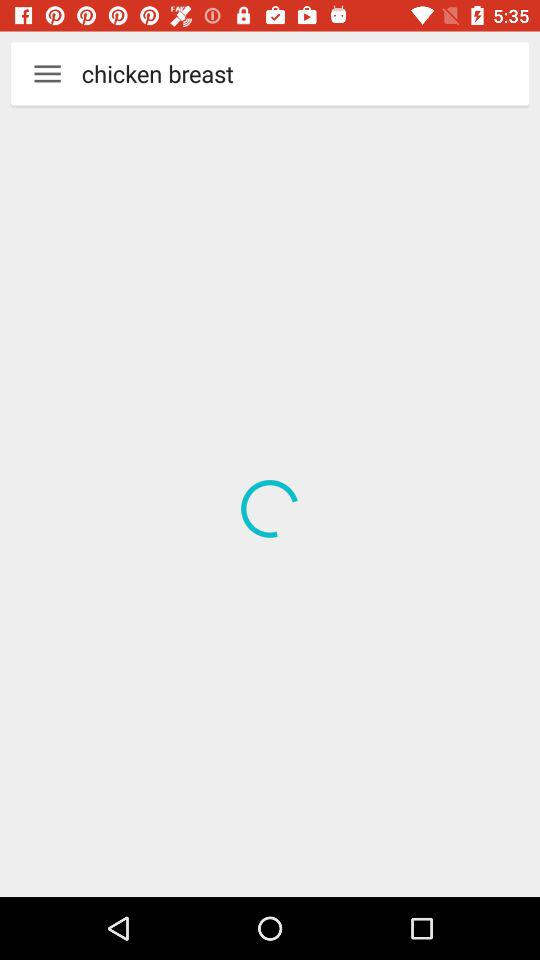What are the different cake options available? The different cake options available are "CAKES CHOCOLATE", "CHOCOLATE CAKE", "CHRISTMAS CAKES" and "CAKES". 